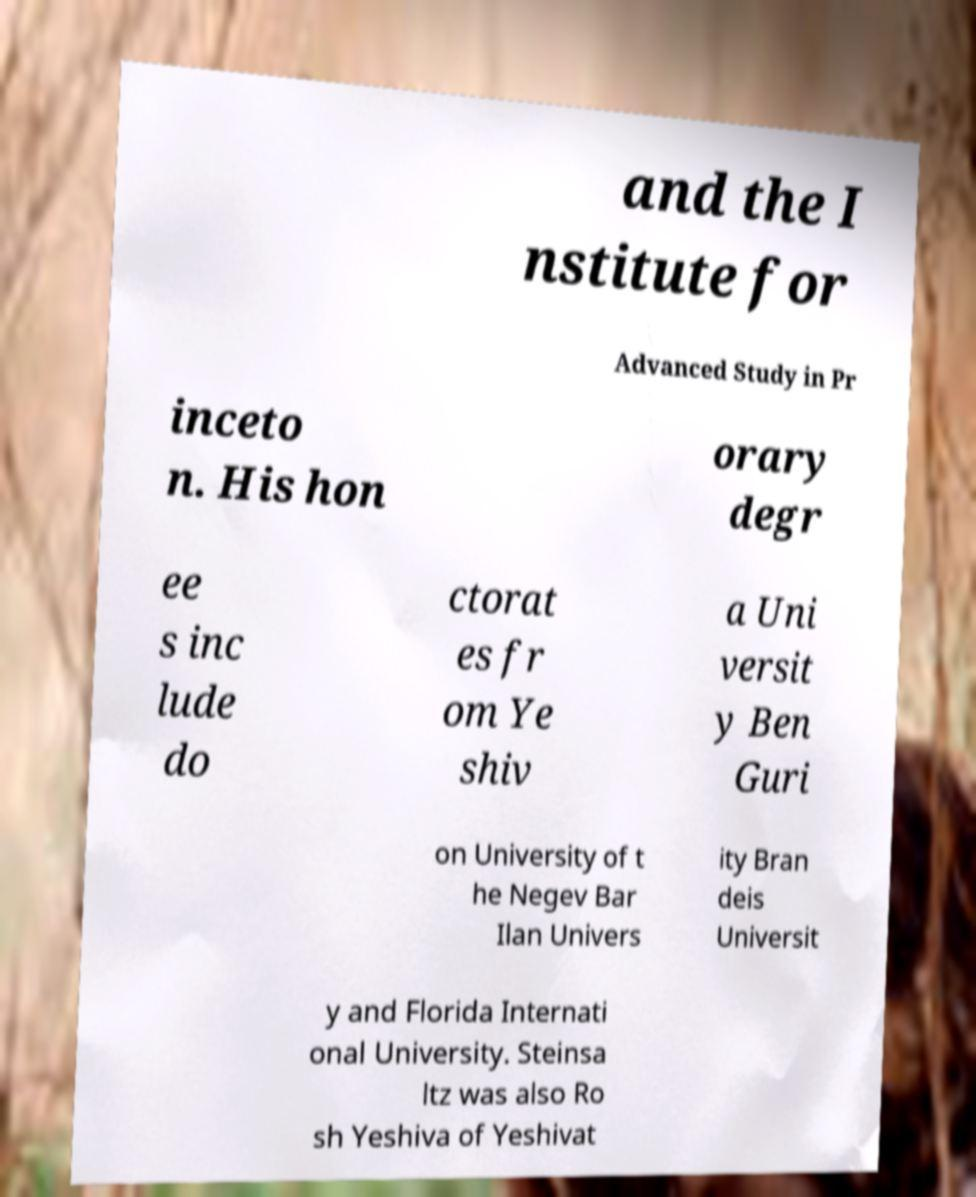Can you read and provide the text displayed in the image?This photo seems to have some interesting text. Can you extract and type it out for me? and the I nstitute for Advanced Study in Pr inceto n. His hon orary degr ee s inc lude do ctorat es fr om Ye shiv a Uni versit y Ben Guri on University of t he Negev Bar Ilan Univers ity Bran deis Universit y and Florida Internati onal University. Steinsa ltz was also Ro sh Yeshiva of Yeshivat 